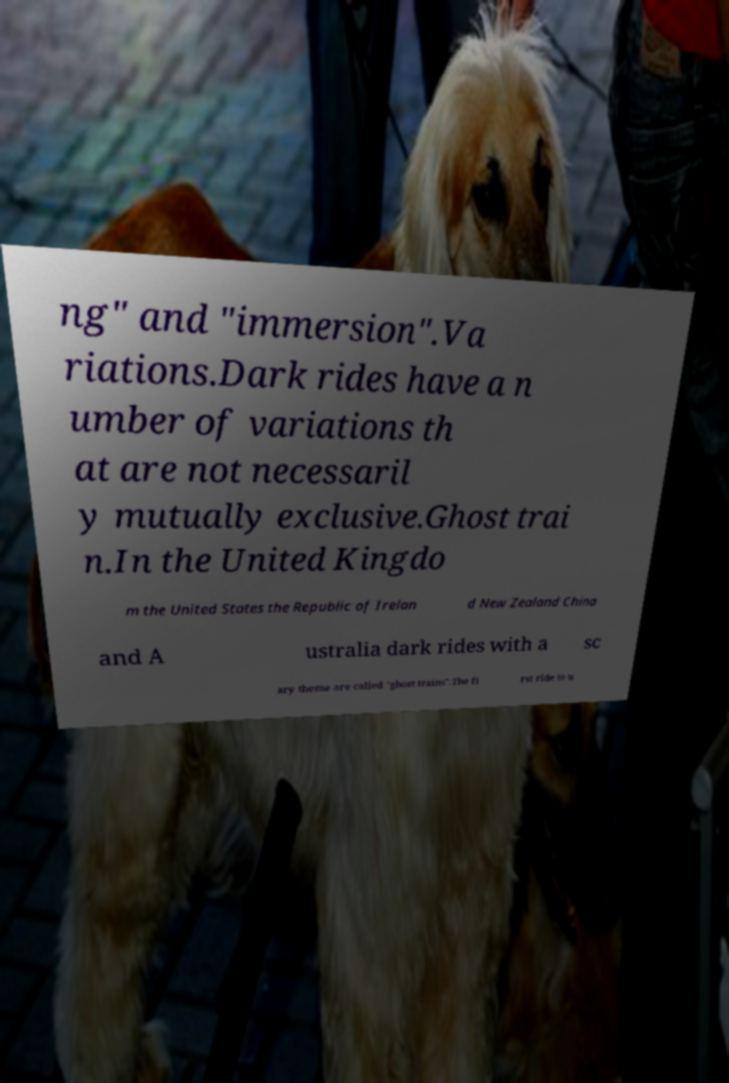What messages or text are displayed in this image? I need them in a readable, typed format. ng" and "immersion".Va riations.Dark rides have a n umber of variations th at are not necessaril y mutually exclusive.Ghost trai n.In the United Kingdo m the United States the Republic of Irelan d New Zealand China and A ustralia dark rides with a sc ary theme are called "ghost trains".The fi rst ride to u 